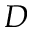Convert formula to latex. <formula><loc_0><loc_0><loc_500><loc_500>D</formula> 